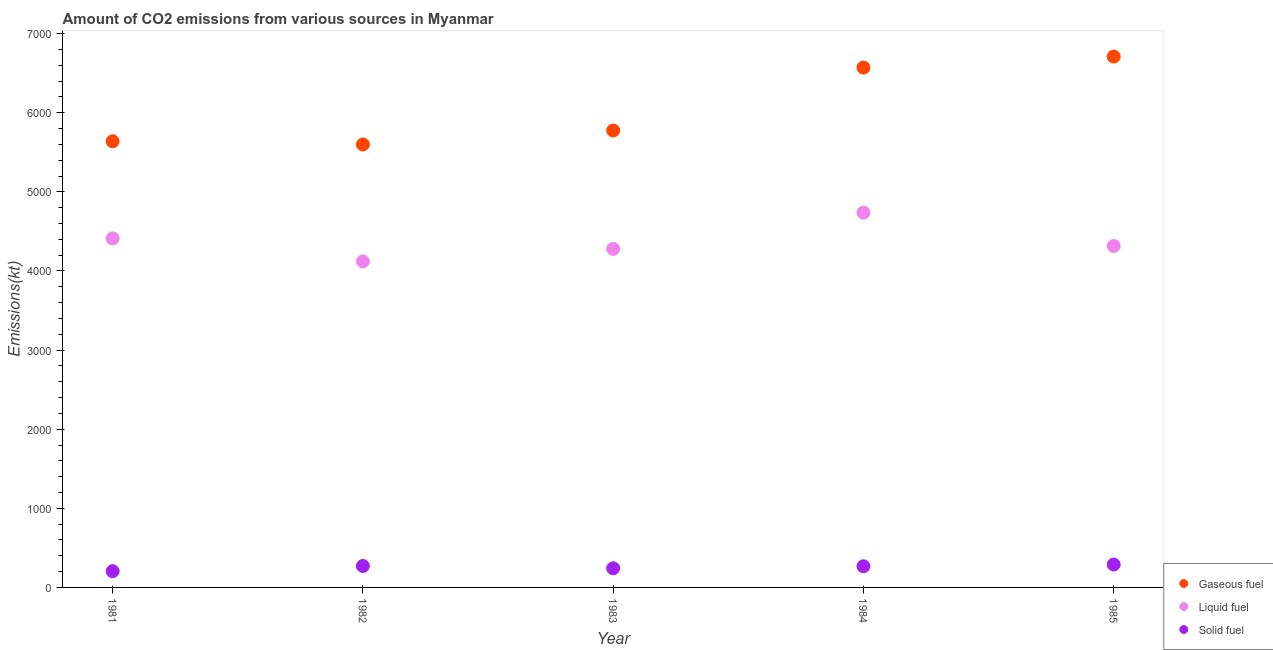How many different coloured dotlines are there?
Make the answer very short. 3. Is the number of dotlines equal to the number of legend labels?
Your answer should be very brief. Yes. What is the amount of co2 emissions from solid fuel in 1984?
Offer a terse response. 267.69. Across all years, what is the maximum amount of co2 emissions from solid fuel?
Your response must be concise. 289.69. Across all years, what is the minimum amount of co2 emissions from solid fuel?
Your answer should be very brief. 205.35. What is the total amount of co2 emissions from liquid fuel in the graph?
Provide a short and direct response. 2.19e+04. What is the difference between the amount of co2 emissions from solid fuel in 1981 and that in 1984?
Give a very brief answer. -62.34. What is the difference between the amount of co2 emissions from liquid fuel in 1982 and the amount of co2 emissions from gaseous fuel in 1981?
Keep it short and to the point. -1518.14. What is the average amount of co2 emissions from solid fuel per year?
Provide a short and direct response. 255.22. In the year 1984, what is the difference between the amount of co2 emissions from gaseous fuel and amount of co2 emissions from liquid fuel?
Provide a succinct answer. 1833.5. What is the ratio of the amount of co2 emissions from solid fuel in 1981 to that in 1985?
Give a very brief answer. 0.71. Is the difference between the amount of co2 emissions from solid fuel in 1983 and 1985 greater than the difference between the amount of co2 emissions from gaseous fuel in 1983 and 1985?
Ensure brevity in your answer.  Yes. What is the difference between the highest and the second highest amount of co2 emissions from solid fuel?
Keep it short and to the point. 18.33. What is the difference between the highest and the lowest amount of co2 emissions from liquid fuel?
Give a very brief answer. 616.06. Does the amount of co2 emissions from liquid fuel monotonically increase over the years?
Your response must be concise. No. Is the amount of co2 emissions from solid fuel strictly greater than the amount of co2 emissions from gaseous fuel over the years?
Keep it short and to the point. No. How many dotlines are there?
Give a very brief answer. 3. How many years are there in the graph?
Your answer should be very brief. 5. What is the difference between two consecutive major ticks on the Y-axis?
Give a very brief answer. 1000. Are the values on the major ticks of Y-axis written in scientific E-notation?
Ensure brevity in your answer.  No. How many legend labels are there?
Make the answer very short. 3. What is the title of the graph?
Ensure brevity in your answer.  Amount of CO2 emissions from various sources in Myanmar. What is the label or title of the X-axis?
Your response must be concise. Year. What is the label or title of the Y-axis?
Offer a very short reply. Emissions(kt). What is the Emissions(kt) of Gaseous fuel in 1981?
Your response must be concise. 5639.85. What is the Emissions(kt) in Liquid fuel in 1981?
Provide a short and direct response. 4411.4. What is the Emissions(kt) of Solid fuel in 1981?
Ensure brevity in your answer.  205.35. What is the Emissions(kt) of Gaseous fuel in 1982?
Offer a terse response. 5599.51. What is the Emissions(kt) in Liquid fuel in 1982?
Make the answer very short. 4121.71. What is the Emissions(kt) of Solid fuel in 1982?
Your answer should be compact. 271.36. What is the Emissions(kt) in Gaseous fuel in 1983?
Ensure brevity in your answer.  5775.52. What is the Emissions(kt) in Liquid fuel in 1983?
Keep it short and to the point. 4279.39. What is the Emissions(kt) in Solid fuel in 1983?
Give a very brief answer. 242.02. What is the Emissions(kt) of Gaseous fuel in 1984?
Give a very brief answer. 6571.26. What is the Emissions(kt) of Liquid fuel in 1984?
Provide a short and direct response. 4737.76. What is the Emissions(kt) of Solid fuel in 1984?
Offer a terse response. 267.69. What is the Emissions(kt) in Gaseous fuel in 1985?
Offer a terse response. 6710.61. What is the Emissions(kt) of Liquid fuel in 1985?
Offer a terse response. 4316.06. What is the Emissions(kt) in Solid fuel in 1985?
Keep it short and to the point. 289.69. Across all years, what is the maximum Emissions(kt) of Gaseous fuel?
Give a very brief answer. 6710.61. Across all years, what is the maximum Emissions(kt) in Liquid fuel?
Provide a succinct answer. 4737.76. Across all years, what is the maximum Emissions(kt) in Solid fuel?
Make the answer very short. 289.69. Across all years, what is the minimum Emissions(kt) of Gaseous fuel?
Your response must be concise. 5599.51. Across all years, what is the minimum Emissions(kt) in Liquid fuel?
Your response must be concise. 4121.71. Across all years, what is the minimum Emissions(kt) in Solid fuel?
Provide a succinct answer. 205.35. What is the total Emissions(kt) in Gaseous fuel in the graph?
Provide a succinct answer. 3.03e+04. What is the total Emissions(kt) in Liquid fuel in the graph?
Your answer should be compact. 2.19e+04. What is the total Emissions(kt) in Solid fuel in the graph?
Provide a short and direct response. 1276.12. What is the difference between the Emissions(kt) of Gaseous fuel in 1981 and that in 1982?
Give a very brief answer. 40.34. What is the difference between the Emissions(kt) in Liquid fuel in 1981 and that in 1982?
Your answer should be compact. 289.69. What is the difference between the Emissions(kt) in Solid fuel in 1981 and that in 1982?
Ensure brevity in your answer.  -66.01. What is the difference between the Emissions(kt) in Gaseous fuel in 1981 and that in 1983?
Offer a terse response. -135.68. What is the difference between the Emissions(kt) of Liquid fuel in 1981 and that in 1983?
Make the answer very short. 132.01. What is the difference between the Emissions(kt) of Solid fuel in 1981 and that in 1983?
Your answer should be very brief. -36.67. What is the difference between the Emissions(kt) in Gaseous fuel in 1981 and that in 1984?
Your response must be concise. -931.42. What is the difference between the Emissions(kt) in Liquid fuel in 1981 and that in 1984?
Provide a short and direct response. -326.36. What is the difference between the Emissions(kt) of Solid fuel in 1981 and that in 1984?
Offer a terse response. -62.34. What is the difference between the Emissions(kt) of Gaseous fuel in 1981 and that in 1985?
Your answer should be very brief. -1070.76. What is the difference between the Emissions(kt) in Liquid fuel in 1981 and that in 1985?
Make the answer very short. 95.34. What is the difference between the Emissions(kt) in Solid fuel in 1981 and that in 1985?
Provide a succinct answer. -84.34. What is the difference between the Emissions(kt) of Gaseous fuel in 1982 and that in 1983?
Give a very brief answer. -176.02. What is the difference between the Emissions(kt) of Liquid fuel in 1982 and that in 1983?
Your response must be concise. -157.68. What is the difference between the Emissions(kt) of Solid fuel in 1982 and that in 1983?
Make the answer very short. 29.34. What is the difference between the Emissions(kt) in Gaseous fuel in 1982 and that in 1984?
Provide a succinct answer. -971.75. What is the difference between the Emissions(kt) in Liquid fuel in 1982 and that in 1984?
Give a very brief answer. -616.06. What is the difference between the Emissions(kt) of Solid fuel in 1982 and that in 1984?
Ensure brevity in your answer.  3.67. What is the difference between the Emissions(kt) in Gaseous fuel in 1982 and that in 1985?
Ensure brevity in your answer.  -1111.1. What is the difference between the Emissions(kt) in Liquid fuel in 1982 and that in 1985?
Make the answer very short. -194.35. What is the difference between the Emissions(kt) of Solid fuel in 1982 and that in 1985?
Provide a succinct answer. -18.34. What is the difference between the Emissions(kt) in Gaseous fuel in 1983 and that in 1984?
Your answer should be compact. -795.74. What is the difference between the Emissions(kt) of Liquid fuel in 1983 and that in 1984?
Offer a very short reply. -458.38. What is the difference between the Emissions(kt) in Solid fuel in 1983 and that in 1984?
Offer a very short reply. -25.67. What is the difference between the Emissions(kt) in Gaseous fuel in 1983 and that in 1985?
Your response must be concise. -935.09. What is the difference between the Emissions(kt) of Liquid fuel in 1983 and that in 1985?
Ensure brevity in your answer.  -36.67. What is the difference between the Emissions(kt) of Solid fuel in 1983 and that in 1985?
Make the answer very short. -47.67. What is the difference between the Emissions(kt) of Gaseous fuel in 1984 and that in 1985?
Your response must be concise. -139.35. What is the difference between the Emissions(kt) of Liquid fuel in 1984 and that in 1985?
Your answer should be compact. 421.7. What is the difference between the Emissions(kt) in Solid fuel in 1984 and that in 1985?
Provide a short and direct response. -22. What is the difference between the Emissions(kt) in Gaseous fuel in 1981 and the Emissions(kt) in Liquid fuel in 1982?
Your answer should be very brief. 1518.14. What is the difference between the Emissions(kt) of Gaseous fuel in 1981 and the Emissions(kt) of Solid fuel in 1982?
Offer a terse response. 5368.49. What is the difference between the Emissions(kt) of Liquid fuel in 1981 and the Emissions(kt) of Solid fuel in 1982?
Keep it short and to the point. 4140.04. What is the difference between the Emissions(kt) in Gaseous fuel in 1981 and the Emissions(kt) in Liquid fuel in 1983?
Ensure brevity in your answer.  1360.46. What is the difference between the Emissions(kt) of Gaseous fuel in 1981 and the Emissions(kt) of Solid fuel in 1983?
Give a very brief answer. 5397.82. What is the difference between the Emissions(kt) in Liquid fuel in 1981 and the Emissions(kt) in Solid fuel in 1983?
Give a very brief answer. 4169.38. What is the difference between the Emissions(kt) in Gaseous fuel in 1981 and the Emissions(kt) in Liquid fuel in 1984?
Your response must be concise. 902.08. What is the difference between the Emissions(kt) of Gaseous fuel in 1981 and the Emissions(kt) of Solid fuel in 1984?
Give a very brief answer. 5372.15. What is the difference between the Emissions(kt) of Liquid fuel in 1981 and the Emissions(kt) of Solid fuel in 1984?
Offer a terse response. 4143.71. What is the difference between the Emissions(kt) in Gaseous fuel in 1981 and the Emissions(kt) in Liquid fuel in 1985?
Make the answer very short. 1323.79. What is the difference between the Emissions(kt) in Gaseous fuel in 1981 and the Emissions(kt) in Solid fuel in 1985?
Your answer should be compact. 5350.15. What is the difference between the Emissions(kt) in Liquid fuel in 1981 and the Emissions(kt) in Solid fuel in 1985?
Provide a short and direct response. 4121.71. What is the difference between the Emissions(kt) of Gaseous fuel in 1982 and the Emissions(kt) of Liquid fuel in 1983?
Offer a terse response. 1320.12. What is the difference between the Emissions(kt) of Gaseous fuel in 1982 and the Emissions(kt) of Solid fuel in 1983?
Your answer should be very brief. 5357.49. What is the difference between the Emissions(kt) of Liquid fuel in 1982 and the Emissions(kt) of Solid fuel in 1983?
Provide a succinct answer. 3879.69. What is the difference between the Emissions(kt) in Gaseous fuel in 1982 and the Emissions(kt) in Liquid fuel in 1984?
Your answer should be very brief. 861.75. What is the difference between the Emissions(kt) of Gaseous fuel in 1982 and the Emissions(kt) of Solid fuel in 1984?
Ensure brevity in your answer.  5331.82. What is the difference between the Emissions(kt) in Liquid fuel in 1982 and the Emissions(kt) in Solid fuel in 1984?
Your response must be concise. 3854.02. What is the difference between the Emissions(kt) of Gaseous fuel in 1982 and the Emissions(kt) of Liquid fuel in 1985?
Offer a very short reply. 1283.45. What is the difference between the Emissions(kt) of Gaseous fuel in 1982 and the Emissions(kt) of Solid fuel in 1985?
Offer a terse response. 5309.82. What is the difference between the Emissions(kt) in Liquid fuel in 1982 and the Emissions(kt) in Solid fuel in 1985?
Make the answer very short. 3832.01. What is the difference between the Emissions(kt) in Gaseous fuel in 1983 and the Emissions(kt) in Liquid fuel in 1984?
Your response must be concise. 1037.76. What is the difference between the Emissions(kt) of Gaseous fuel in 1983 and the Emissions(kt) of Solid fuel in 1984?
Your answer should be compact. 5507.83. What is the difference between the Emissions(kt) of Liquid fuel in 1983 and the Emissions(kt) of Solid fuel in 1984?
Keep it short and to the point. 4011.7. What is the difference between the Emissions(kt) in Gaseous fuel in 1983 and the Emissions(kt) in Liquid fuel in 1985?
Your response must be concise. 1459.47. What is the difference between the Emissions(kt) of Gaseous fuel in 1983 and the Emissions(kt) of Solid fuel in 1985?
Keep it short and to the point. 5485.83. What is the difference between the Emissions(kt) in Liquid fuel in 1983 and the Emissions(kt) in Solid fuel in 1985?
Your response must be concise. 3989.7. What is the difference between the Emissions(kt) of Gaseous fuel in 1984 and the Emissions(kt) of Liquid fuel in 1985?
Your response must be concise. 2255.2. What is the difference between the Emissions(kt) in Gaseous fuel in 1984 and the Emissions(kt) in Solid fuel in 1985?
Make the answer very short. 6281.57. What is the difference between the Emissions(kt) of Liquid fuel in 1984 and the Emissions(kt) of Solid fuel in 1985?
Make the answer very short. 4448.07. What is the average Emissions(kt) of Gaseous fuel per year?
Offer a very short reply. 6059.35. What is the average Emissions(kt) of Liquid fuel per year?
Your response must be concise. 4373.26. What is the average Emissions(kt) in Solid fuel per year?
Make the answer very short. 255.22. In the year 1981, what is the difference between the Emissions(kt) in Gaseous fuel and Emissions(kt) in Liquid fuel?
Your response must be concise. 1228.44. In the year 1981, what is the difference between the Emissions(kt) of Gaseous fuel and Emissions(kt) of Solid fuel?
Make the answer very short. 5434.49. In the year 1981, what is the difference between the Emissions(kt) in Liquid fuel and Emissions(kt) in Solid fuel?
Provide a succinct answer. 4206.05. In the year 1982, what is the difference between the Emissions(kt) of Gaseous fuel and Emissions(kt) of Liquid fuel?
Offer a very short reply. 1477.8. In the year 1982, what is the difference between the Emissions(kt) of Gaseous fuel and Emissions(kt) of Solid fuel?
Provide a succinct answer. 5328.15. In the year 1982, what is the difference between the Emissions(kt) in Liquid fuel and Emissions(kt) in Solid fuel?
Your answer should be compact. 3850.35. In the year 1983, what is the difference between the Emissions(kt) of Gaseous fuel and Emissions(kt) of Liquid fuel?
Keep it short and to the point. 1496.14. In the year 1983, what is the difference between the Emissions(kt) in Gaseous fuel and Emissions(kt) in Solid fuel?
Your response must be concise. 5533.5. In the year 1983, what is the difference between the Emissions(kt) of Liquid fuel and Emissions(kt) of Solid fuel?
Offer a terse response. 4037.37. In the year 1984, what is the difference between the Emissions(kt) in Gaseous fuel and Emissions(kt) in Liquid fuel?
Your response must be concise. 1833.5. In the year 1984, what is the difference between the Emissions(kt) of Gaseous fuel and Emissions(kt) of Solid fuel?
Your answer should be compact. 6303.57. In the year 1984, what is the difference between the Emissions(kt) in Liquid fuel and Emissions(kt) in Solid fuel?
Your response must be concise. 4470.07. In the year 1985, what is the difference between the Emissions(kt) of Gaseous fuel and Emissions(kt) of Liquid fuel?
Offer a terse response. 2394.55. In the year 1985, what is the difference between the Emissions(kt) of Gaseous fuel and Emissions(kt) of Solid fuel?
Your response must be concise. 6420.92. In the year 1985, what is the difference between the Emissions(kt) in Liquid fuel and Emissions(kt) in Solid fuel?
Keep it short and to the point. 4026.37. What is the ratio of the Emissions(kt) in Gaseous fuel in 1981 to that in 1982?
Give a very brief answer. 1.01. What is the ratio of the Emissions(kt) in Liquid fuel in 1981 to that in 1982?
Your answer should be compact. 1.07. What is the ratio of the Emissions(kt) of Solid fuel in 1981 to that in 1982?
Give a very brief answer. 0.76. What is the ratio of the Emissions(kt) in Gaseous fuel in 1981 to that in 1983?
Make the answer very short. 0.98. What is the ratio of the Emissions(kt) of Liquid fuel in 1981 to that in 1983?
Your answer should be very brief. 1.03. What is the ratio of the Emissions(kt) in Solid fuel in 1981 to that in 1983?
Offer a very short reply. 0.85. What is the ratio of the Emissions(kt) of Gaseous fuel in 1981 to that in 1984?
Give a very brief answer. 0.86. What is the ratio of the Emissions(kt) in Liquid fuel in 1981 to that in 1984?
Offer a very short reply. 0.93. What is the ratio of the Emissions(kt) in Solid fuel in 1981 to that in 1984?
Your answer should be very brief. 0.77. What is the ratio of the Emissions(kt) in Gaseous fuel in 1981 to that in 1985?
Give a very brief answer. 0.84. What is the ratio of the Emissions(kt) in Liquid fuel in 1981 to that in 1985?
Offer a very short reply. 1.02. What is the ratio of the Emissions(kt) of Solid fuel in 1981 to that in 1985?
Keep it short and to the point. 0.71. What is the ratio of the Emissions(kt) in Gaseous fuel in 1982 to that in 1983?
Offer a terse response. 0.97. What is the ratio of the Emissions(kt) of Liquid fuel in 1982 to that in 1983?
Give a very brief answer. 0.96. What is the ratio of the Emissions(kt) of Solid fuel in 1982 to that in 1983?
Offer a very short reply. 1.12. What is the ratio of the Emissions(kt) in Gaseous fuel in 1982 to that in 1984?
Ensure brevity in your answer.  0.85. What is the ratio of the Emissions(kt) in Liquid fuel in 1982 to that in 1984?
Your response must be concise. 0.87. What is the ratio of the Emissions(kt) of Solid fuel in 1982 to that in 1984?
Ensure brevity in your answer.  1.01. What is the ratio of the Emissions(kt) in Gaseous fuel in 1982 to that in 1985?
Offer a very short reply. 0.83. What is the ratio of the Emissions(kt) in Liquid fuel in 1982 to that in 1985?
Provide a short and direct response. 0.95. What is the ratio of the Emissions(kt) of Solid fuel in 1982 to that in 1985?
Your response must be concise. 0.94. What is the ratio of the Emissions(kt) of Gaseous fuel in 1983 to that in 1984?
Provide a short and direct response. 0.88. What is the ratio of the Emissions(kt) of Liquid fuel in 1983 to that in 1984?
Ensure brevity in your answer.  0.9. What is the ratio of the Emissions(kt) of Solid fuel in 1983 to that in 1984?
Offer a terse response. 0.9. What is the ratio of the Emissions(kt) in Gaseous fuel in 1983 to that in 1985?
Keep it short and to the point. 0.86. What is the ratio of the Emissions(kt) of Liquid fuel in 1983 to that in 1985?
Your answer should be very brief. 0.99. What is the ratio of the Emissions(kt) of Solid fuel in 1983 to that in 1985?
Provide a succinct answer. 0.84. What is the ratio of the Emissions(kt) in Gaseous fuel in 1984 to that in 1985?
Offer a very short reply. 0.98. What is the ratio of the Emissions(kt) in Liquid fuel in 1984 to that in 1985?
Your answer should be compact. 1.1. What is the ratio of the Emissions(kt) of Solid fuel in 1984 to that in 1985?
Make the answer very short. 0.92. What is the difference between the highest and the second highest Emissions(kt) of Gaseous fuel?
Your answer should be compact. 139.35. What is the difference between the highest and the second highest Emissions(kt) in Liquid fuel?
Your answer should be compact. 326.36. What is the difference between the highest and the second highest Emissions(kt) in Solid fuel?
Ensure brevity in your answer.  18.34. What is the difference between the highest and the lowest Emissions(kt) of Gaseous fuel?
Ensure brevity in your answer.  1111.1. What is the difference between the highest and the lowest Emissions(kt) of Liquid fuel?
Your answer should be very brief. 616.06. What is the difference between the highest and the lowest Emissions(kt) in Solid fuel?
Provide a short and direct response. 84.34. 